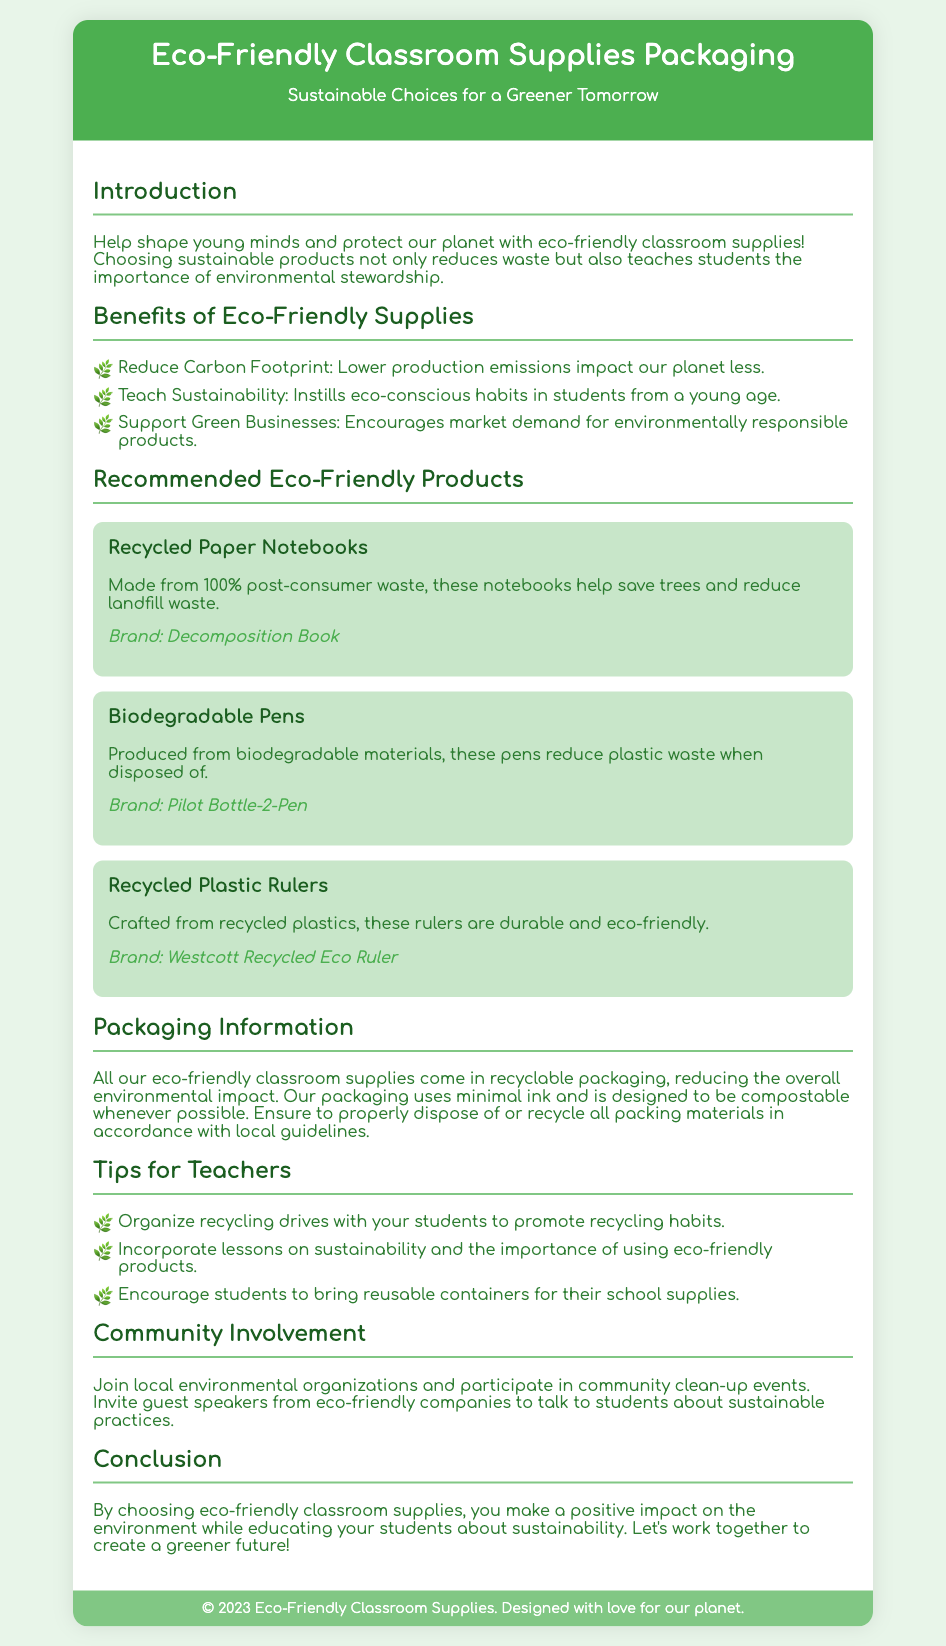What is the title of the document? The title of the document is found in the header section of the document.
Answer: Eco-Friendly Classroom Supplies Packaging What brand produces the recycled paper notebooks? The brand information is provided under each recommended product in the document.
Answer: Decomposition Book What type of pens are mentioned as biodegradable? The document specifies the type of eco-friendly product in the recommended section.
Answer: Biodegradable Pens What is one benefit of using eco-friendly supplies? The benefits are listed in the section about eco-friendly supplies in the document.
Answer: Reduce Carbon Footprint What packaging information is provided for the classroom supplies? The packaging information discusses the type and disposal of packaging materials in a specific section.
Answer: Recyclable packaging How does the document suggest teachers promote recycling habits? The document mentions tips for teachers on ways to engage students in sustainability.
Answer: Organize recycling drives What is one incentive for supporting green businesses? The section detailing benefits outlines why it's important to purchase eco-friendly products.
Answer: Encourages market demand How often is the document's copyright updated? The copyright statement at the bottom of the document indicates the frequency of updates.
Answer: 2023 